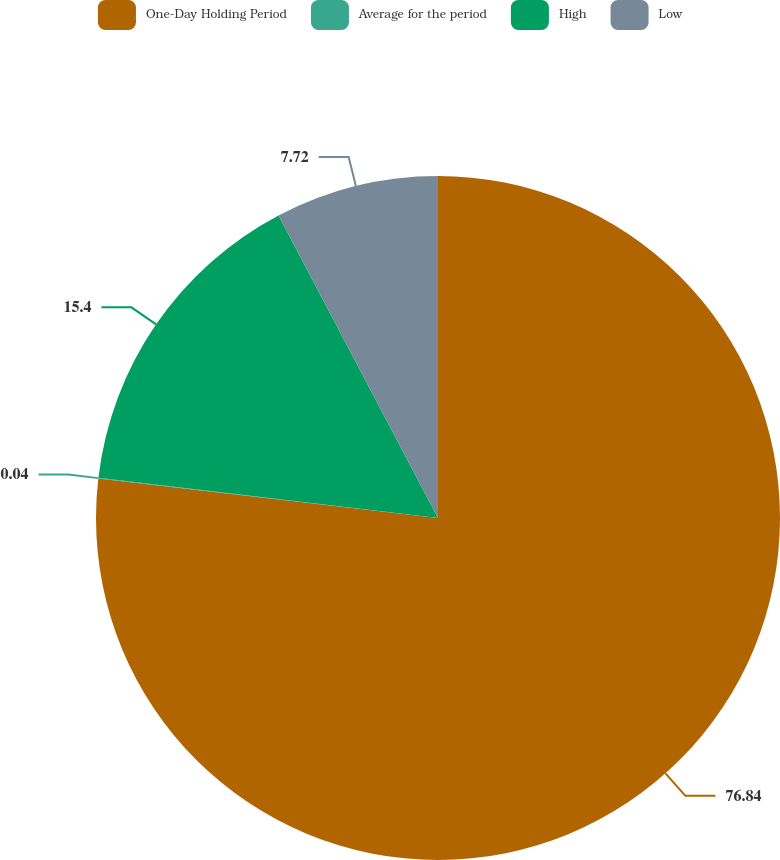Convert chart to OTSL. <chart><loc_0><loc_0><loc_500><loc_500><pie_chart><fcel>One-Day Holding Period<fcel>Average for the period<fcel>High<fcel>Low<nl><fcel>76.84%<fcel>0.04%<fcel>15.4%<fcel>7.72%<nl></chart> 